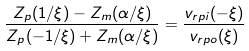Convert formula to latex. <formula><loc_0><loc_0><loc_500><loc_500>\frac { Z _ { p } ( 1 / \xi ) - Z _ { m } ( \alpha / \xi ) } { Z _ { p } ( - 1 / \xi ) + Z _ { m } ( \alpha / \xi ) } = \frac { v _ { r p i } ( - \xi ) } { v _ { r p o } ( \xi ) }</formula> 